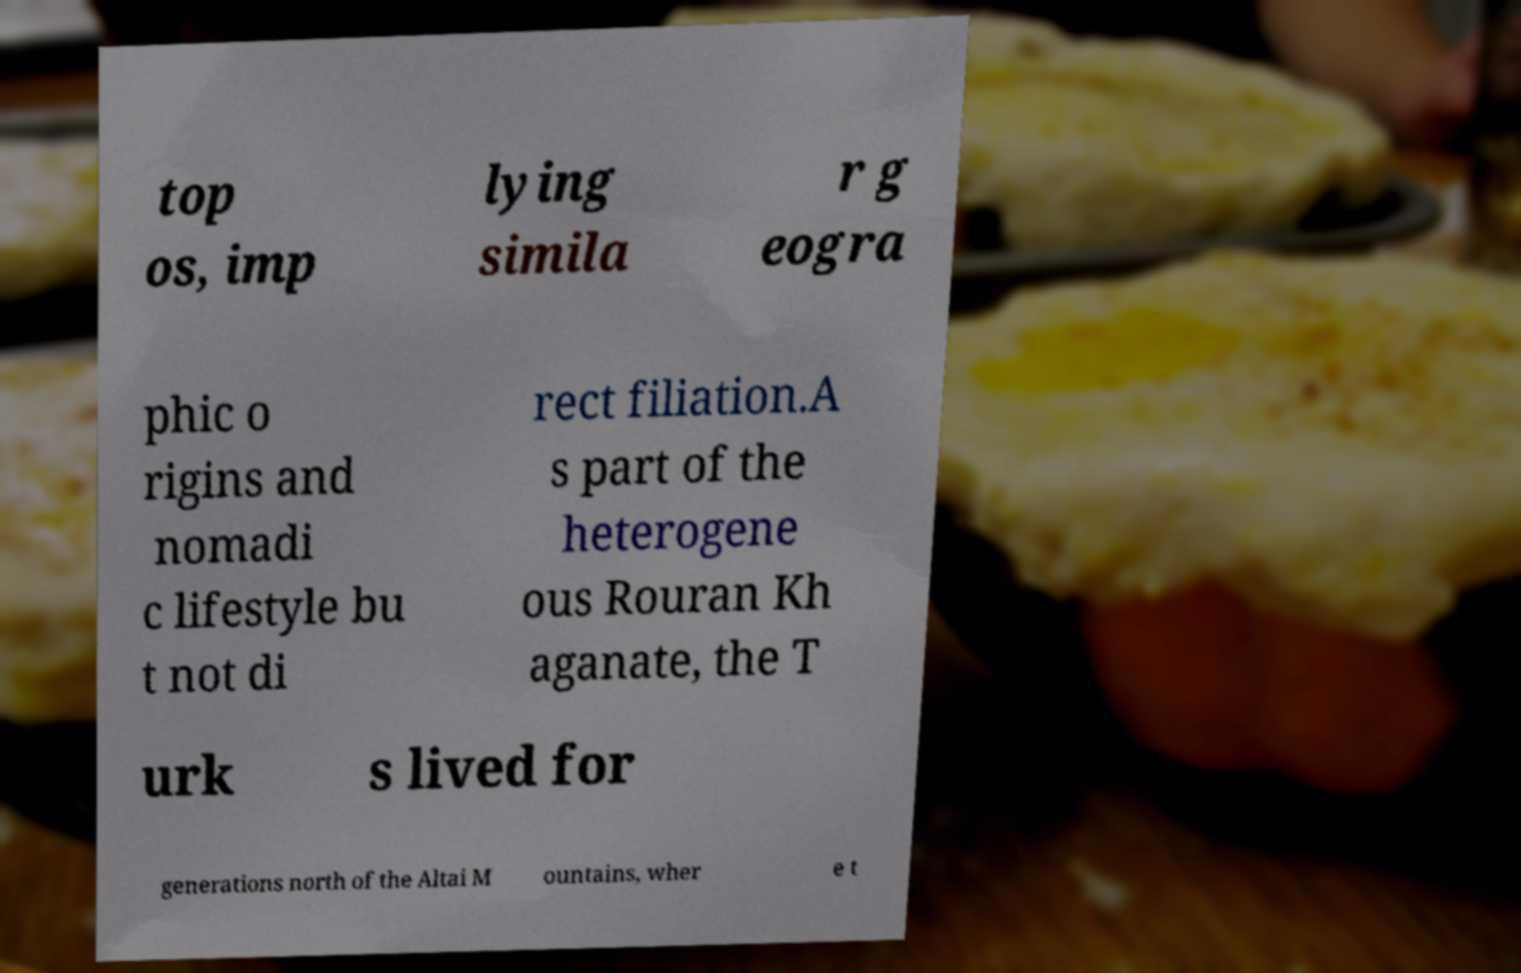Could you extract and type out the text from this image? top os, imp lying simila r g eogra phic o rigins and nomadi c lifestyle bu t not di rect filiation.A s part of the heterogene ous Rouran Kh aganate, the T urk s lived for generations north of the Altai M ountains, wher e t 